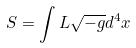Convert formula to latex. <formula><loc_0><loc_0><loc_500><loc_500>S = \int L \sqrt { - g } d ^ { 4 } x</formula> 